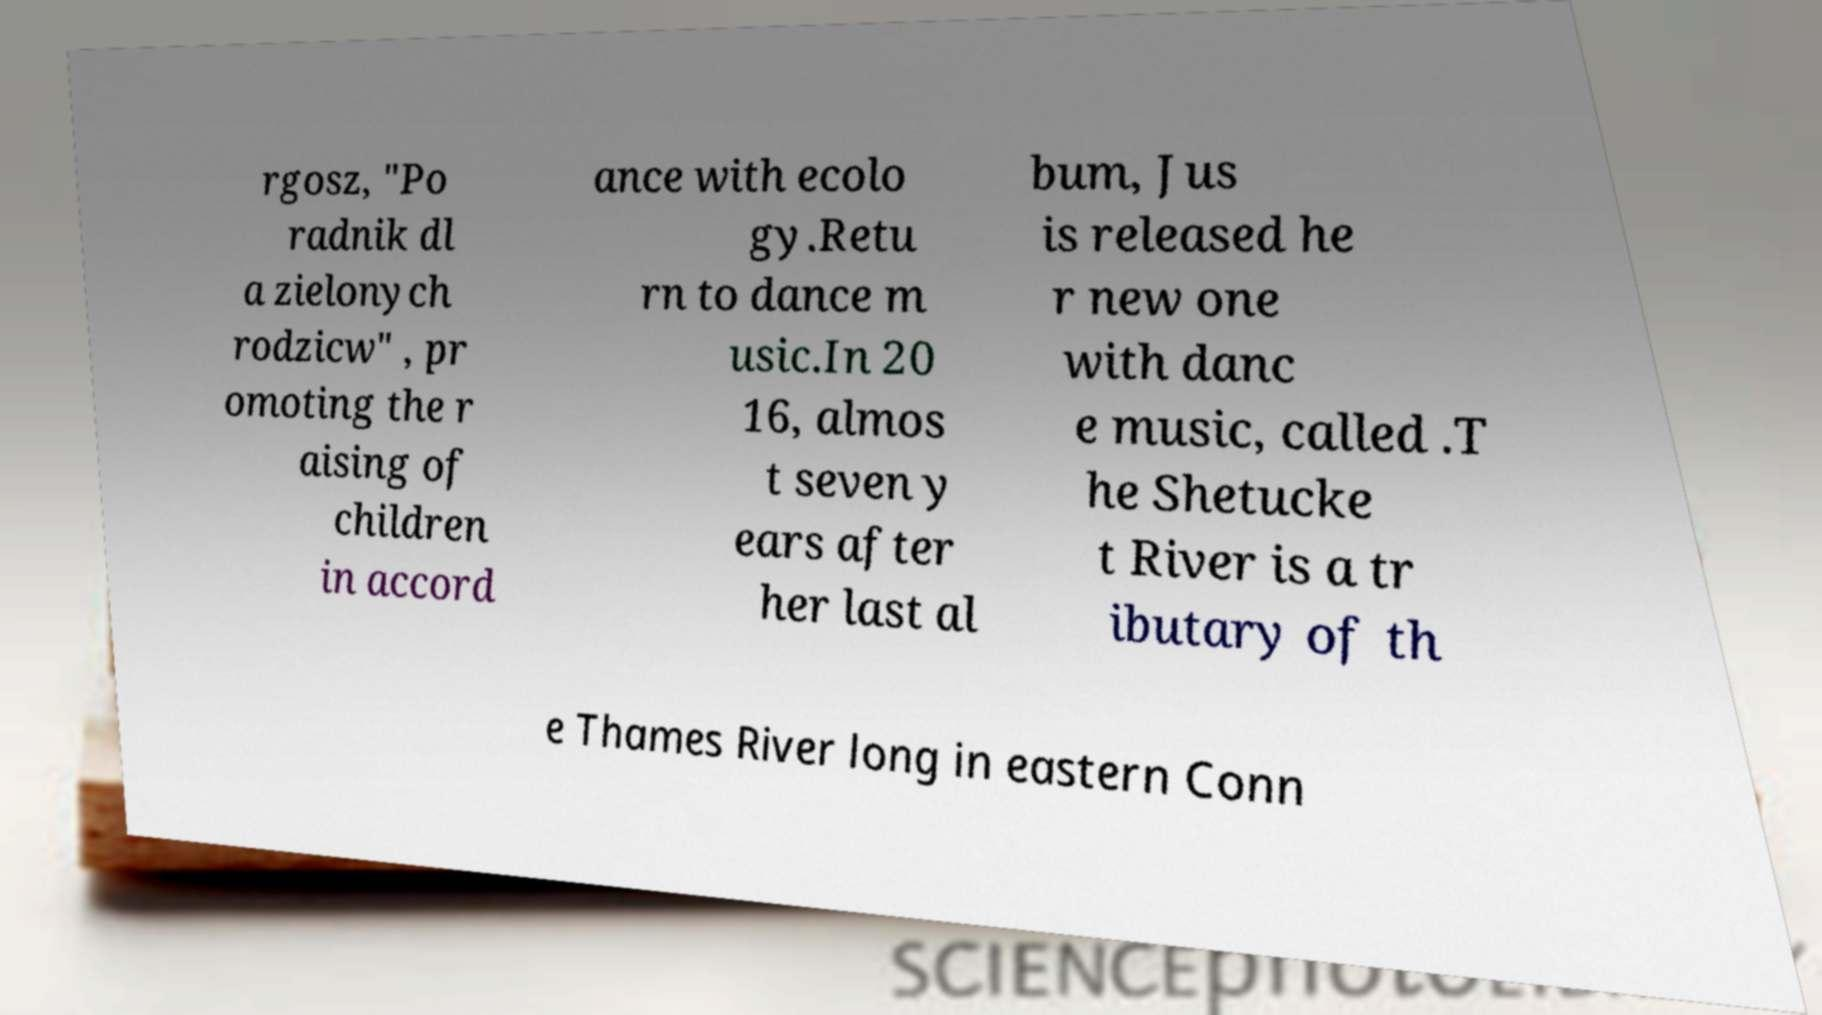For documentation purposes, I need the text within this image transcribed. Could you provide that? rgosz, "Po radnik dl a zielonych rodzicw" , pr omoting the r aising of children in accord ance with ecolo gy.Retu rn to dance m usic.In 20 16, almos t seven y ears after her last al bum, Jus is released he r new one with danc e music, called .T he Shetucke t River is a tr ibutary of th e Thames River long in eastern Conn 